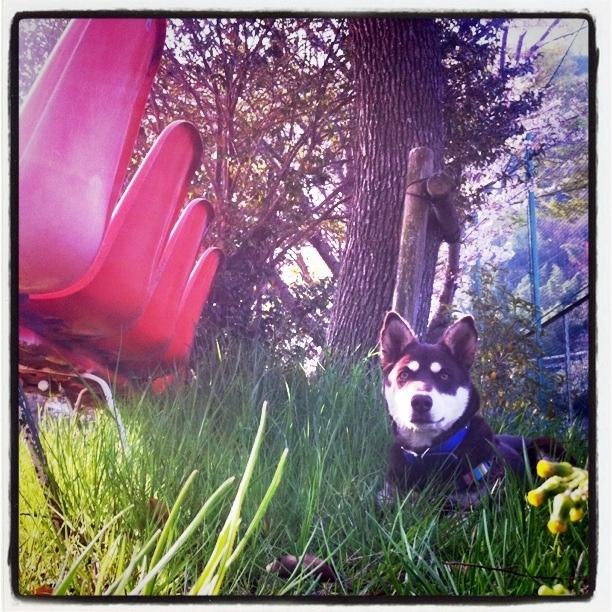Is the backyard clean?
Concise answer only. No. Is there red chairs in this picture?
Quick response, please. Yes. What is by the dogs right back paw?
Keep it brief. Grass. Is the dog looking at the camera?
Quick response, please. Yes. 